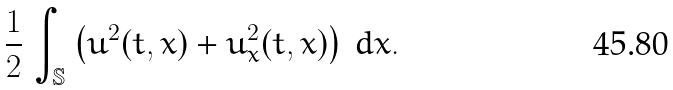Convert formula to latex. <formula><loc_0><loc_0><loc_500><loc_500>\frac { 1 } { 2 } \, \int _ { \mathbb { S } } \left ( u ^ { 2 } ( t , x ) + u ^ { 2 } _ { x } ( t , x ) \right ) \, d x .</formula> 